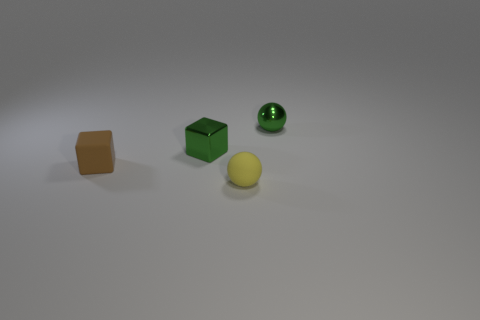Add 2 tiny green cubes. How many objects exist? 6 Subtract all small brown cylinders. Subtract all small blocks. How many objects are left? 2 Add 1 small metal spheres. How many small metal spheres are left? 2 Add 4 tiny matte objects. How many tiny matte objects exist? 6 Subtract 0 yellow cylinders. How many objects are left? 4 